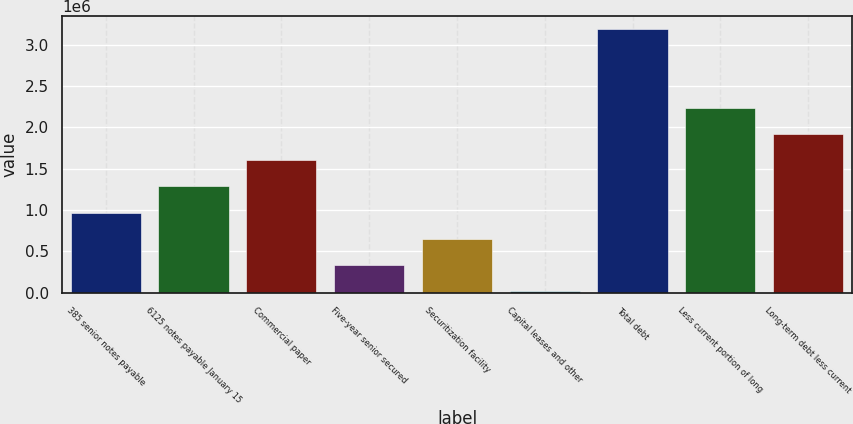Convert chart to OTSL. <chart><loc_0><loc_0><loc_500><loc_500><bar_chart><fcel>385 senior notes payable<fcel>6125 notes payable January 15<fcel>Commercial paper<fcel>Five-year senior secured<fcel>Securitization facility<fcel>Capital leases and other<fcel>Total debt<fcel>Less current portion of long<fcel>Long-term debt less current<nl><fcel>969608<fcel>1.28721e+06<fcel>1.60481e+06<fcel>334406<fcel>652007<fcel>16805<fcel>3.19282e+06<fcel>2.24001e+06<fcel>1.92241e+06<nl></chart> 